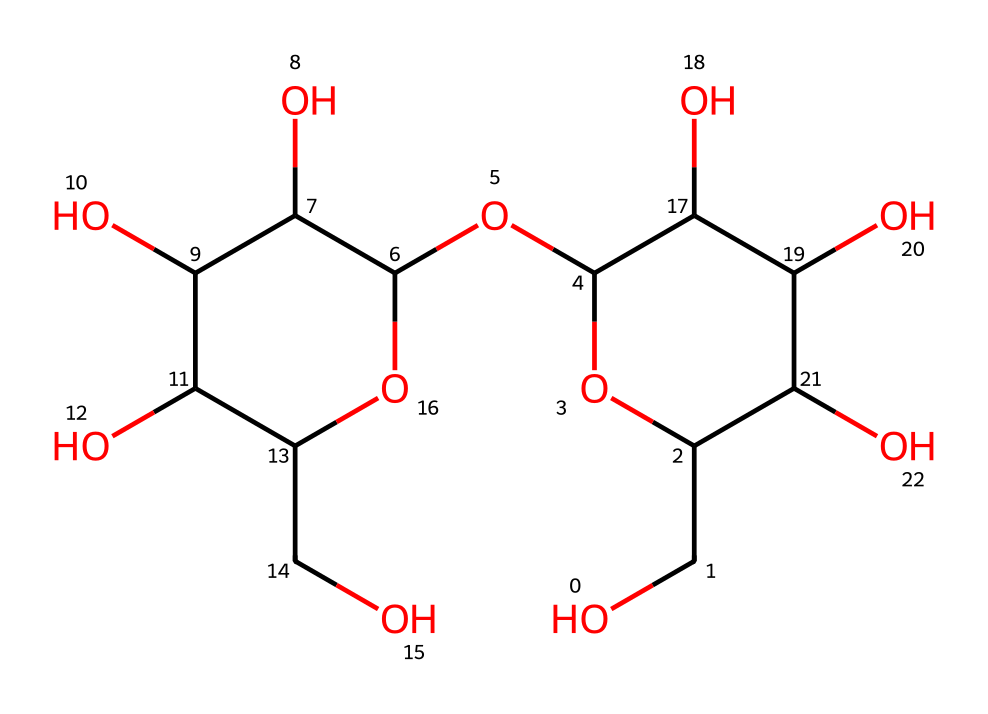What is the molecular formula of this compound? To determine the molecular formula, count the number of each type of atom represented in the SMILES string. From the structure, we identify the presence of carbon (C), hydrogen (H), and oxygen (O). Counting each gives C6, H12, and O6. Therefore, the molecular formula is C6H12O6.
Answer: C6H12O6 How many hydroxyl groups are present in this molecule? The SMILES notation shows multiple [OH] groups, which indicates the presence of hydroxyl (-OH) functional groups. By analyzing the structure, we can identify each -OH group, totaling 6 hydroxyl groups.
Answer: 6 What type of monomer is represented by this structure? The structural composition, which includes multiple hydroxy groups and a ring structure, is characteristic of a sugar monomer, specifically a hexose sugar like glucose or fructose. These are fundamental building blocks of carbohydrates.
Answer: sugar What significance does the presence of hydroxyl groups have for the behavior of paper? The hydroxyl (-OH) groups in the monomer enhance hydrogen bonding and moisture absorption, which is crucial for the paper's ability to preserve documents by preventing brittleness and enhancing flexibility.
Answer: moisture absorption How does the molecular structure affect the solubility of this compound in water? The presence of multiple hydroxyl groups creates favorable interactions with water molecules, leading to increased solubility. This is because the polar -OH groups can form hydrogen bonds with water, making the compound hydrophilic.
Answer: increased solubility 